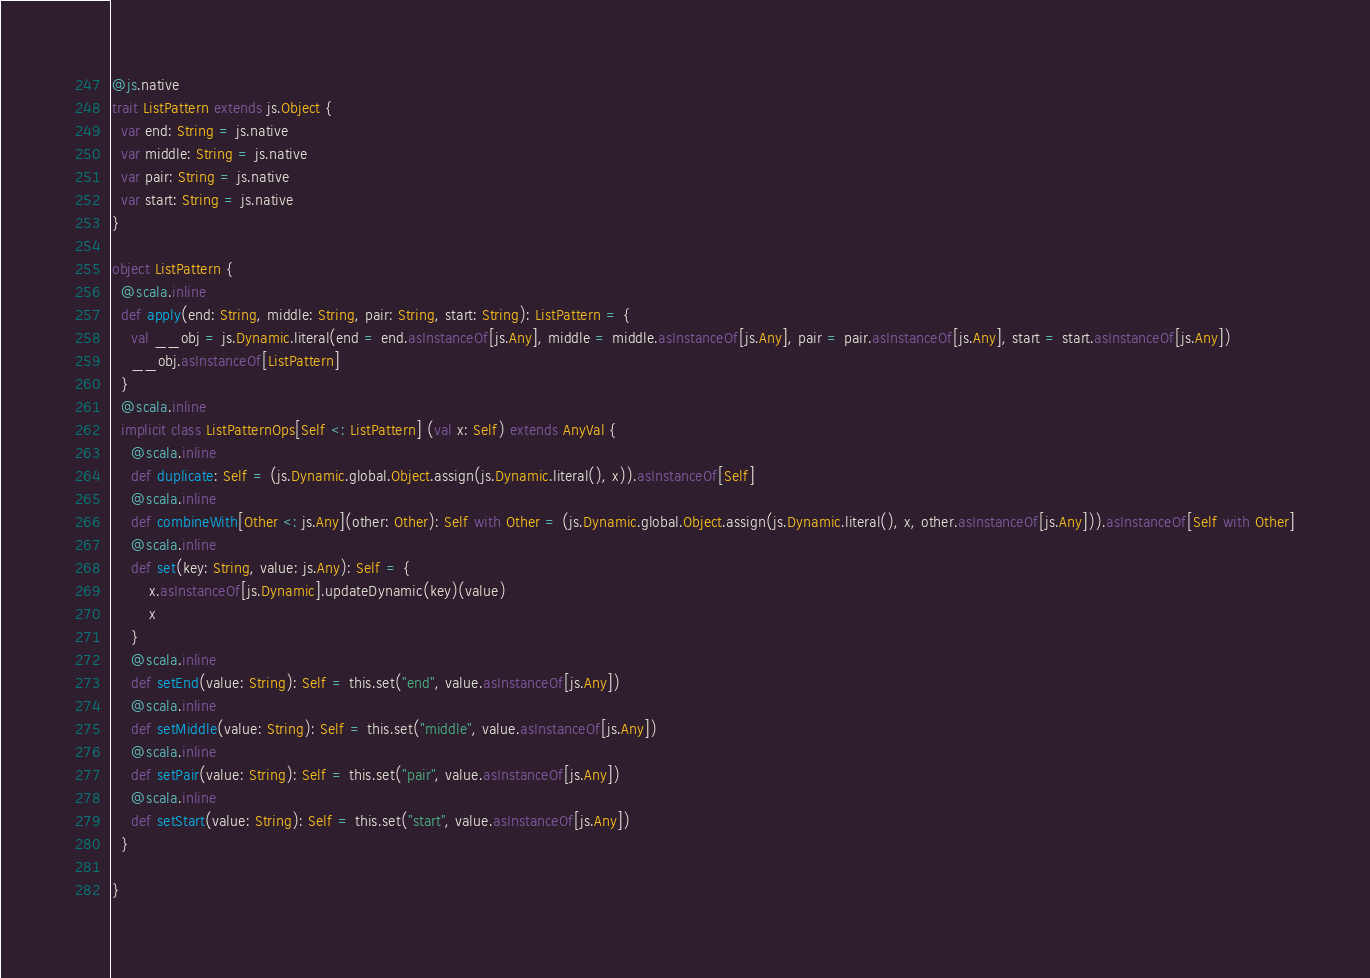Convert code to text. <code><loc_0><loc_0><loc_500><loc_500><_Scala_>
@js.native
trait ListPattern extends js.Object {
  var end: String = js.native
  var middle: String = js.native
  var pair: String = js.native
  var start: String = js.native
}

object ListPattern {
  @scala.inline
  def apply(end: String, middle: String, pair: String, start: String): ListPattern = {
    val __obj = js.Dynamic.literal(end = end.asInstanceOf[js.Any], middle = middle.asInstanceOf[js.Any], pair = pair.asInstanceOf[js.Any], start = start.asInstanceOf[js.Any])
    __obj.asInstanceOf[ListPattern]
  }
  @scala.inline
  implicit class ListPatternOps[Self <: ListPattern] (val x: Self) extends AnyVal {
    @scala.inline
    def duplicate: Self = (js.Dynamic.global.Object.assign(js.Dynamic.literal(), x)).asInstanceOf[Self]
    @scala.inline
    def combineWith[Other <: js.Any](other: Other): Self with Other = (js.Dynamic.global.Object.assign(js.Dynamic.literal(), x, other.asInstanceOf[js.Any])).asInstanceOf[Self with Other]
    @scala.inline
    def set(key: String, value: js.Any): Self = {
        x.asInstanceOf[js.Dynamic].updateDynamic(key)(value)
        x
    }
    @scala.inline
    def setEnd(value: String): Self = this.set("end", value.asInstanceOf[js.Any])
    @scala.inline
    def setMiddle(value: String): Self = this.set("middle", value.asInstanceOf[js.Any])
    @scala.inline
    def setPair(value: String): Self = this.set("pair", value.asInstanceOf[js.Any])
    @scala.inline
    def setStart(value: String): Self = this.set("start", value.asInstanceOf[js.Any])
  }
  
}

</code> 